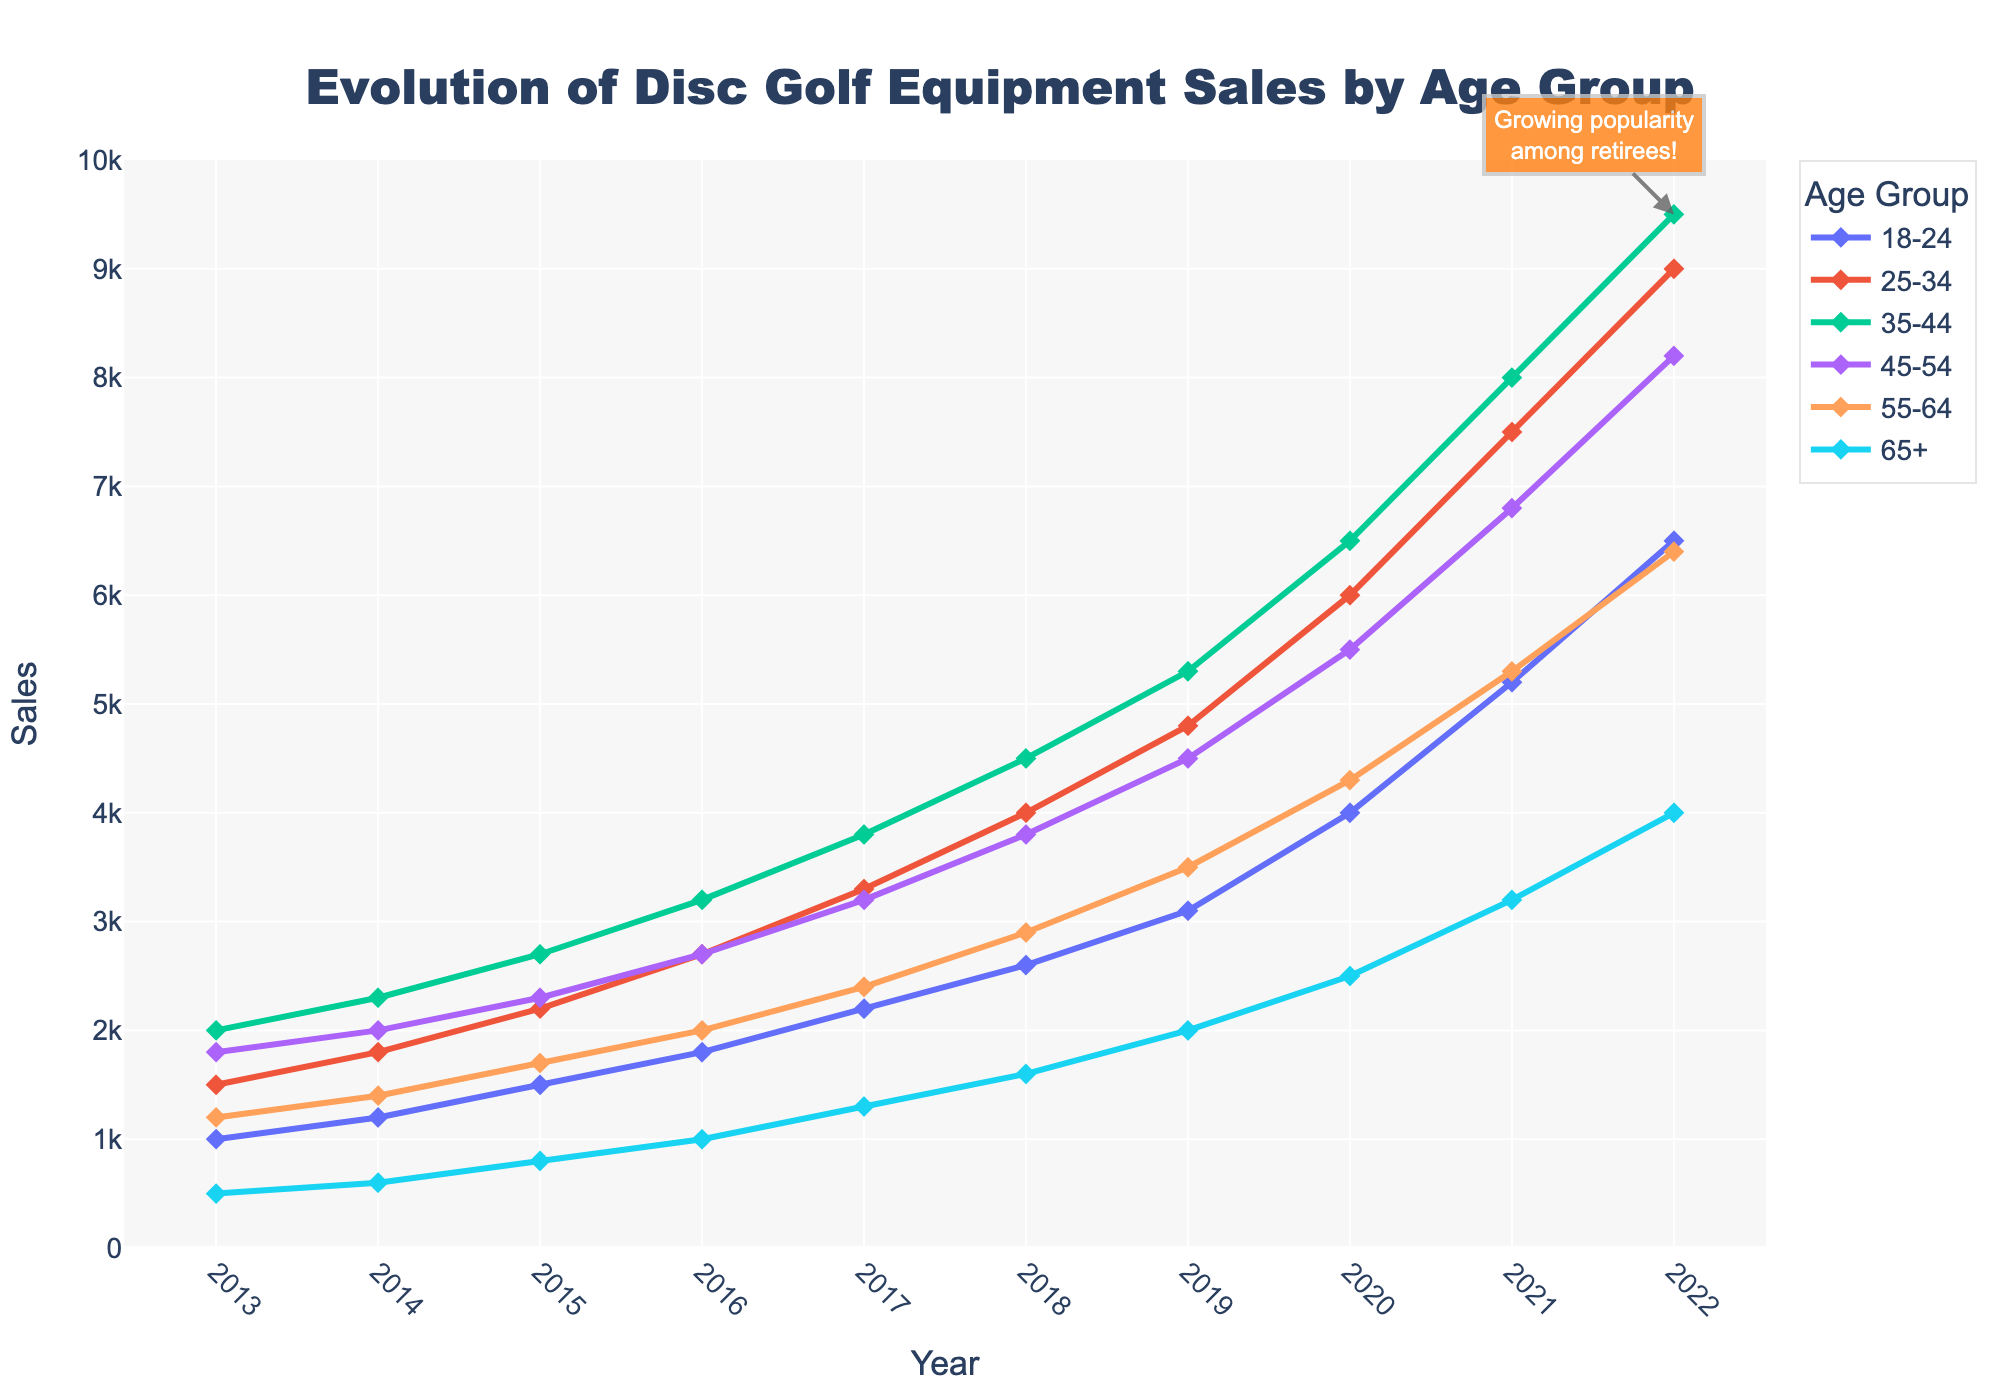What age group saw the highest increase in sales from 2013 to 2022? To find this, calculate the difference in sales from 2013 to 2022 for each age group and determine which one has the largest increase. "65+" increased from 500 to 4000 (+3500), "55-64" increased from 1200 to 6400 (+5200), "45-54" increased from 1800 to 8200 (+6400), "35-44" increased from 2000 to 9500 (+7500), "25-34" increased from 1500 to 9000 (+7500), and "18-24" increased from 1000 to 6500 (+5500). Hence, "25-34" and "35-44" saw the highest increases (+7500).
Answer: 35-44 and 25-34 Which age group had the highest sales in 2022? Look at the end of the lines in the figure for the year 2022 and find the highest point among the groups. The "35-44" age group reached the highest sales at 9500.
Answer: 35-44 How did the sales for the 65+ age group evolve from 2013 to 2022? Observe the line corresponding to the "65+" age group. The sales started at 500 in 2013 and gradually increased each year, reaching 4000 in 2022.
Answer: Gradually increased In which year did the senior age group (65+) first surpass 2000 in sales? Follow the line for the "65+" age group and identify the year when sales crossed the 2000 mark. Sales for the "65+" age group exceeded 2000 for the first time in 2019.
Answer: 2019 Compare the increase in sales from 2020 to 2021 for the 18-24 and 25-34 age groups. Which one had a larger increase? Calculate the difference in sales for each group between 2020 and 2021. For "18-24" group, the increase is 5200 - 4000 = 1200; for "25-34" group, the increase is 7500 - 6000 = 1500. The "25-34" group had a larger increase.
Answer: 25-34 By how much did the sales for the 35-44 age group surpass the 45-54 age group in 2022? Look at the sales for both the "35-44" and "45-54" age groups in 2022: "35-44" had 9500, and "45-54" had 8200. Calculate the difference, which is 9500 - 8200 = 1300.
Answer: 1300 What was the highest annual increase in sales for the 55-64 age group over the decade? Review the year-to-year changes in sales for "55-64" and identify the largest increase. Notable increases are from 2400 to 2900 between 2017 and 2018 (+500), and from 3500 to 4300 between 2019 and 2020 (+800). The largest increase is 800.
Answer: 800 Which age group experienced the lowest sales in 2013 and what was the value? Check the sales values for 2013 for all the age groups and find the lowest one. The "65+" age group had the lowest sales at 500.
Answer: 65+, 500 Across all age groups, which year showed the most significant overall growth in sales? Calculate the year-over-year increases for each age group and sum them up for each year. The year 2020 saw high growth across all age groups with significant jumps: "18-24" increased by 900, "25-34" by 1200, "35-44" by 1200, "45-54" by 1000, "55-64" by 800, and "65+" by 500. The total increase is 5600.
Answer: 2020 